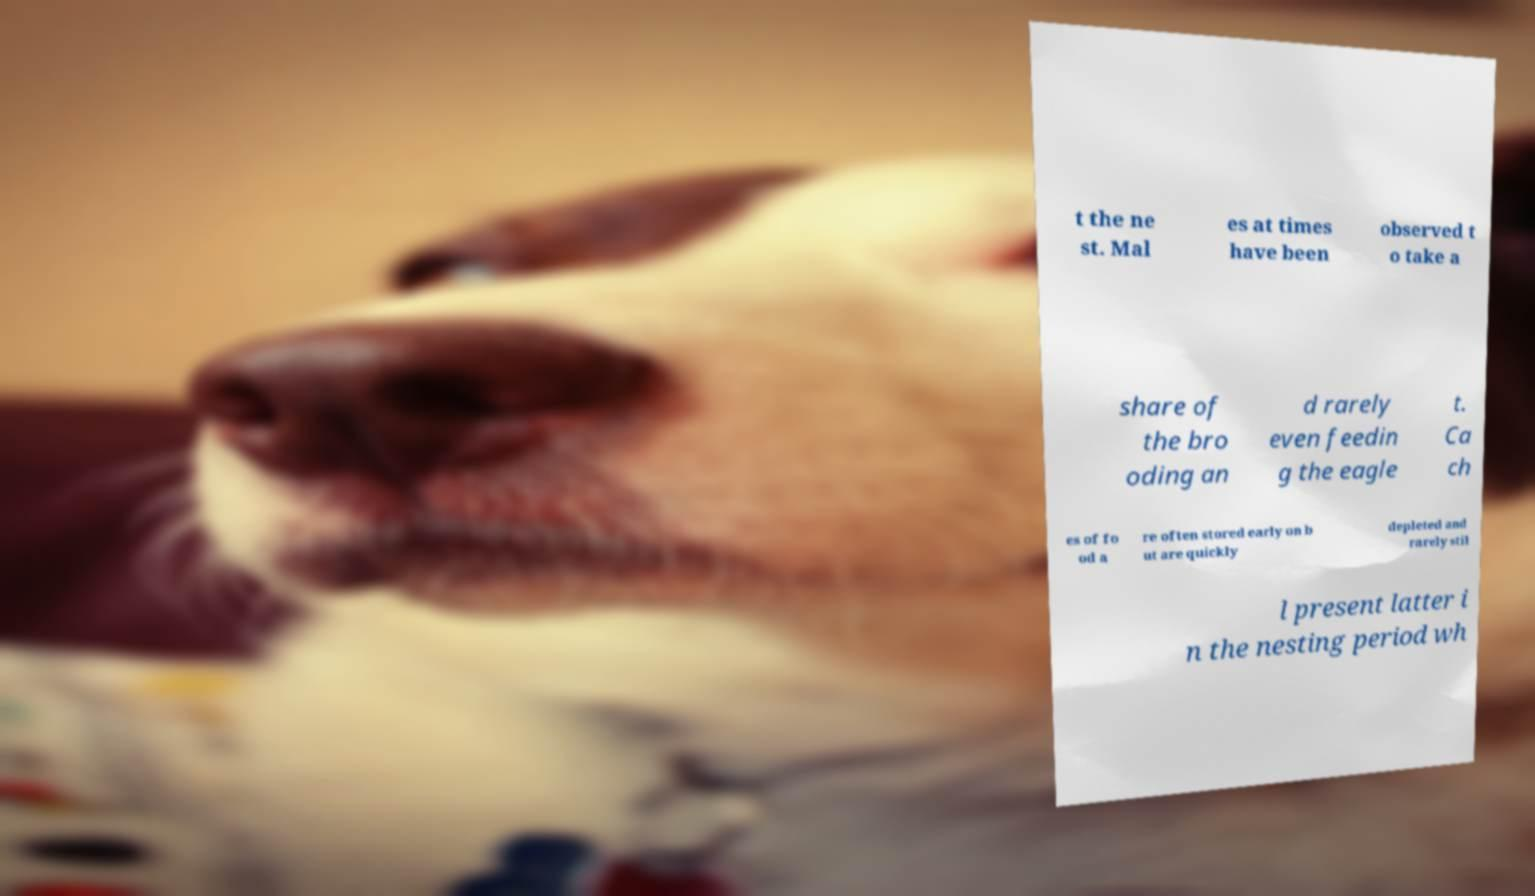There's text embedded in this image that I need extracted. Can you transcribe it verbatim? t the ne st. Mal es at times have been observed t o take a share of the bro oding an d rarely even feedin g the eagle t. Ca ch es of fo od a re often stored early on b ut are quickly depleted and rarely stil l present latter i n the nesting period wh 